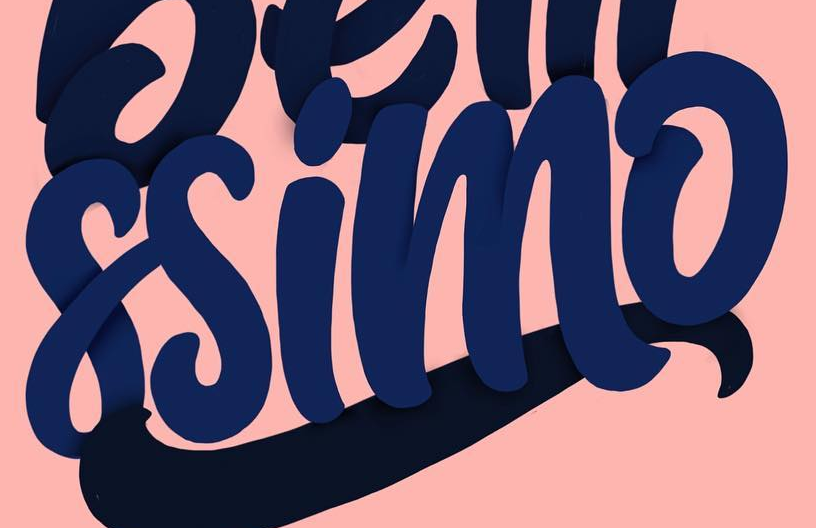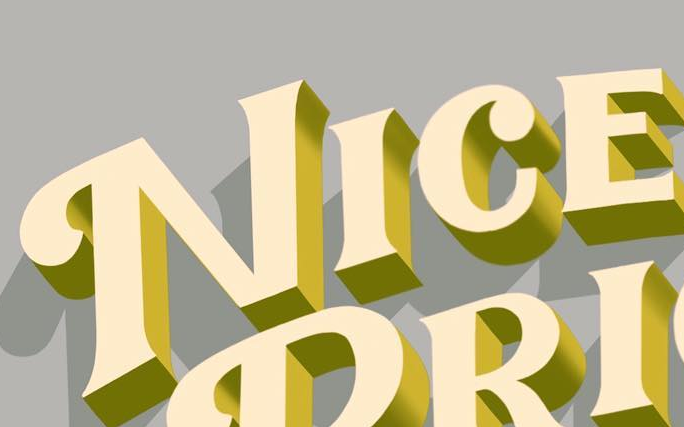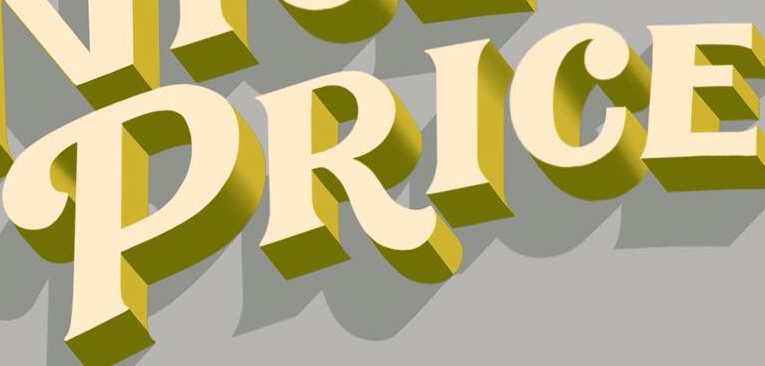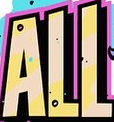Transcribe the words shown in these images in order, separated by a semicolon. ssimo; NICE; PRICE; ALL 